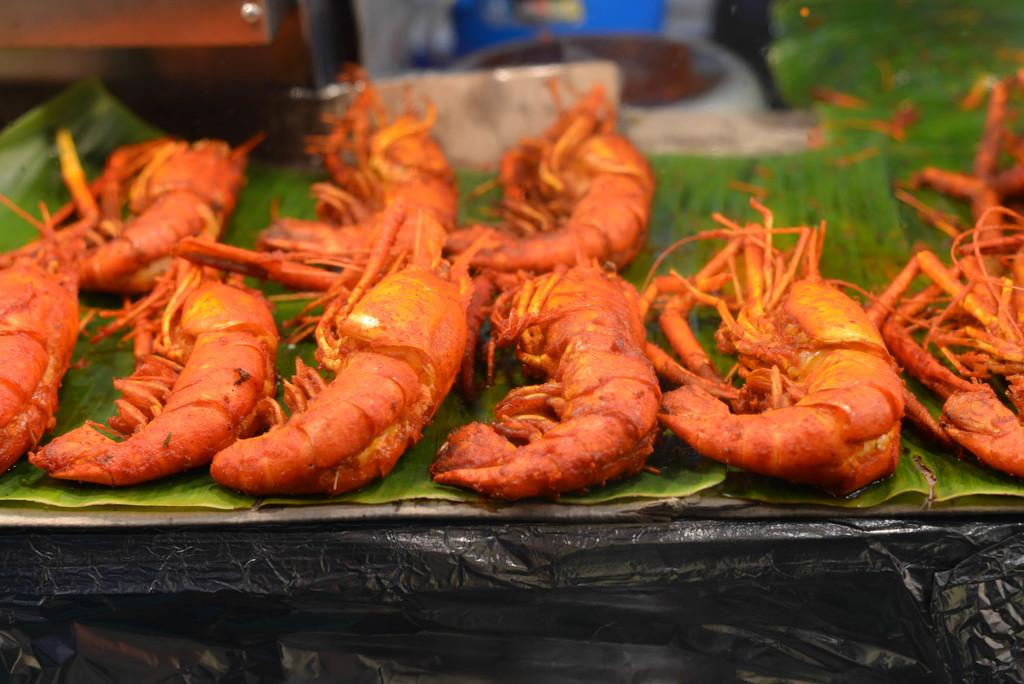What is the food placed on in the image? The food is placed on a leaf in the image. Where is the leaf located? The leaf is on a table. What can be seen in the left top area of the image? There are unspecified objects in the left top area of the image. What is the size of the cow in the image? There is no cow present in the image. 